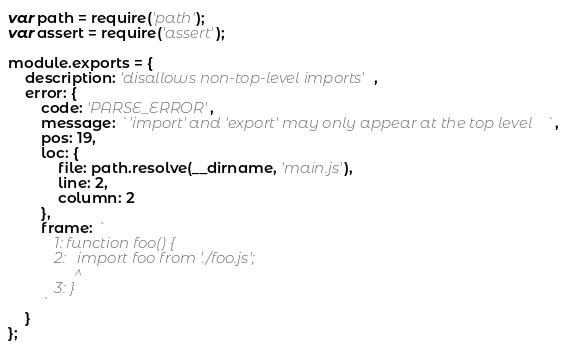Convert code to text. <code><loc_0><loc_0><loc_500><loc_500><_JavaScript_>var path = require('path');
var assert = require('assert');

module.exports = {
	description: 'disallows non-top-level imports',
	error: {
		code: 'PARSE_ERROR',
		message: `'import' and 'export' may only appear at the top level`,
		pos: 19,
		loc: {
			file: path.resolve(__dirname, 'main.js'),
			line: 2,
			column: 2
		},
		frame: `
			1: function foo() {
			2:   import foo from './foo.js';
			     ^
			3: }
		`
	}
};
</code> 